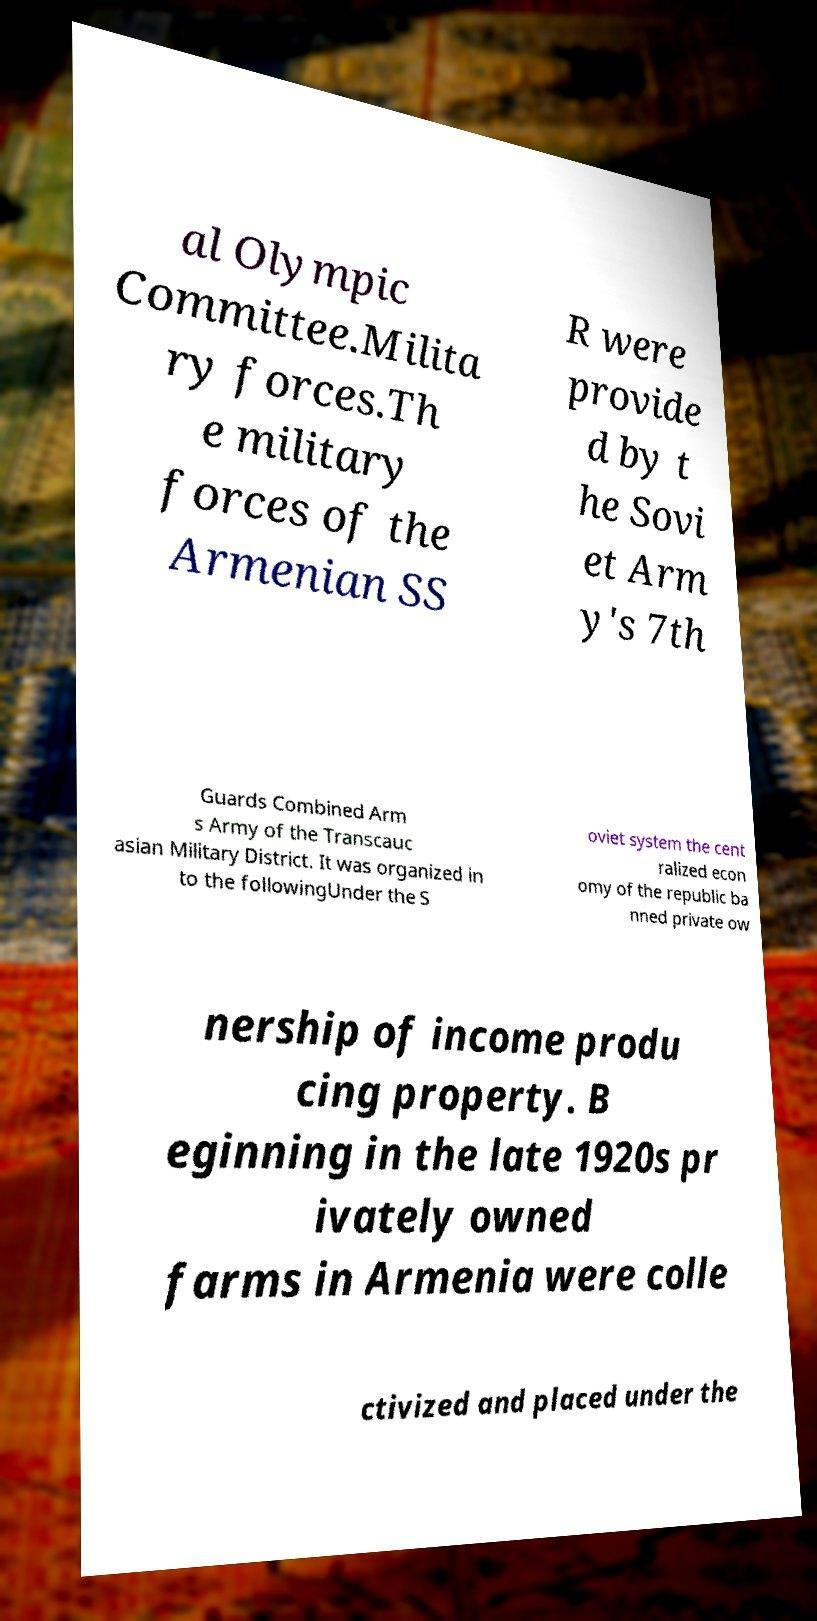Could you extract and type out the text from this image? al Olympic Committee.Milita ry forces.Th e military forces of the Armenian SS R were provide d by t he Sovi et Arm y's 7th Guards Combined Arm s Army of the Transcauc asian Military District. It was organized in to the followingUnder the S oviet system the cent ralized econ omy of the republic ba nned private ow nership of income produ cing property. B eginning in the late 1920s pr ivately owned farms in Armenia were colle ctivized and placed under the 